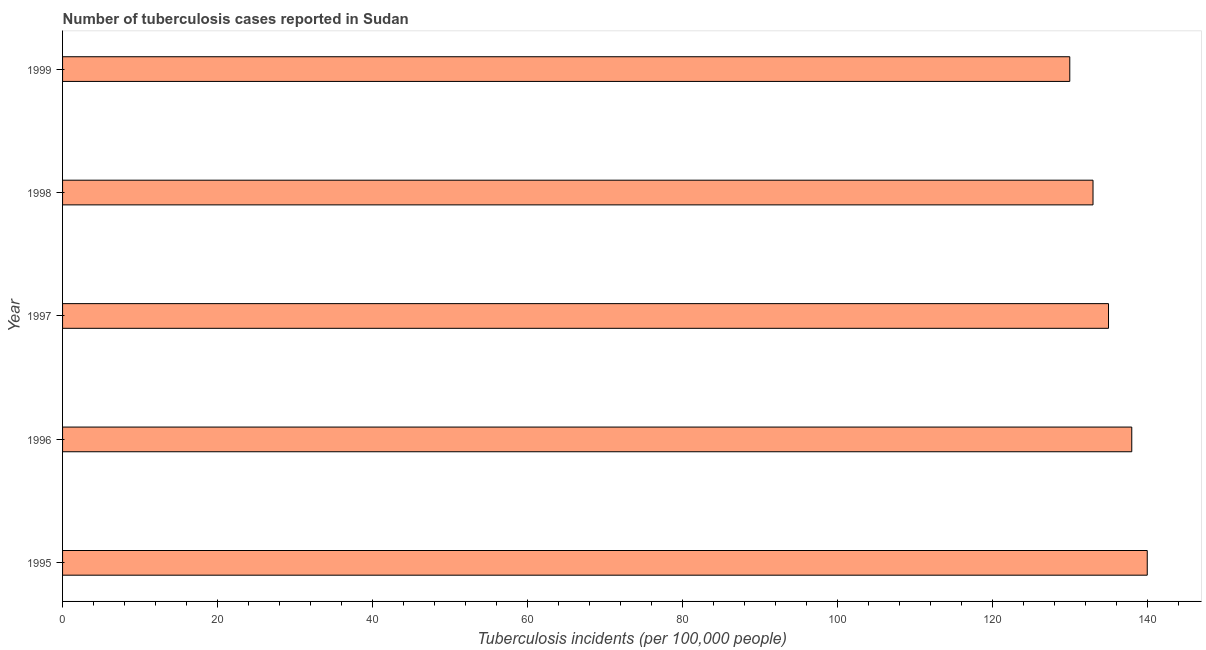Does the graph contain any zero values?
Offer a very short reply. No. What is the title of the graph?
Your answer should be very brief. Number of tuberculosis cases reported in Sudan. What is the label or title of the X-axis?
Give a very brief answer. Tuberculosis incidents (per 100,0 people). What is the label or title of the Y-axis?
Your answer should be very brief. Year. What is the number of tuberculosis incidents in 1998?
Keep it short and to the point. 133. Across all years, what is the maximum number of tuberculosis incidents?
Give a very brief answer. 140. Across all years, what is the minimum number of tuberculosis incidents?
Offer a terse response. 130. In which year was the number of tuberculosis incidents maximum?
Provide a short and direct response. 1995. What is the sum of the number of tuberculosis incidents?
Offer a terse response. 676. What is the average number of tuberculosis incidents per year?
Your response must be concise. 135. What is the median number of tuberculosis incidents?
Your response must be concise. 135. Do a majority of the years between 1995 and 1996 (inclusive) have number of tuberculosis incidents greater than 52 ?
Provide a succinct answer. Yes. Is the number of tuberculosis incidents in 1997 less than that in 1999?
Your answer should be very brief. No. What is the difference between the highest and the second highest number of tuberculosis incidents?
Keep it short and to the point. 2. What is the difference between the highest and the lowest number of tuberculosis incidents?
Your answer should be very brief. 10. In how many years, is the number of tuberculosis incidents greater than the average number of tuberculosis incidents taken over all years?
Provide a succinct answer. 2. How many bars are there?
Your answer should be very brief. 5. Are the values on the major ticks of X-axis written in scientific E-notation?
Provide a succinct answer. No. What is the Tuberculosis incidents (per 100,000 people) in 1995?
Provide a short and direct response. 140. What is the Tuberculosis incidents (per 100,000 people) of 1996?
Give a very brief answer. 138. What is the Tuberculosis incidents (per 100,000 people) of 1997?
Ensure brevity in your answer.  135. What is the Tuberculosis incidents (per 100,000 people) in 1998?
Keep it short and to the point. 133. What is the Tuberculosis incidents (per 100,000 people) in 1999?
Your answer should be compact. 130. What is the difference between the Tuberculosis incidents (per 100,000 people) in 1995 and 1996?
Offer a terse response. 2. What is the difference between the Tuberculosis incidents (per 100,000 people) in 1996 and 1999?
Give a very brief answer. 8. What is the difference between the Tuberculosis incidents (per 100,000 people) in 1997 and 1999?
Your answer should be very brief. 5. What is the difference between the Tuberculosis incidents (per 100,000 people) in 1998 and 1999?
Ensure brevity in your answer.  3. What is the ratio of the Tuberculosis incidents (per 100,000 people) in 1995 to that in 1996?
Your answer should be compact. 1.01. What is the ratio of the Tuberculosis incidents (per 100,000 people) in 1995 to that in 1998?
Your answer should be compact. 1.05. What is the ratio of the Tuberculosis incidents (per 100,000 people) in 1995 to that in 1999?
Provide a short and direct response. 1.08. What is the ratio of the Tuberculosis incidents (per 100,000 people) in 1996 to that in 1997?
Provide a short and direct response. 1.02. What is the ratio of the Tuberculosis incidents (per 100,000 people) in 1996 to that in 1998?
Your answer should be very brief. 1.04. What is the ratio of the Tuberculosis incidents (per 100,000 people) in 1996 to that in 1999?
Your response must be concise. 1.06. What is the ratio of the Tuberculosis incidents (per 100,000 people) in 1997 to that in 1998?
Offer a terse response. 1.01. What is the ratio of the Tuberculosis incidents (per 100,000 people) in 1997 to that in 1999?
Keep it short and to the point. 1.04. 